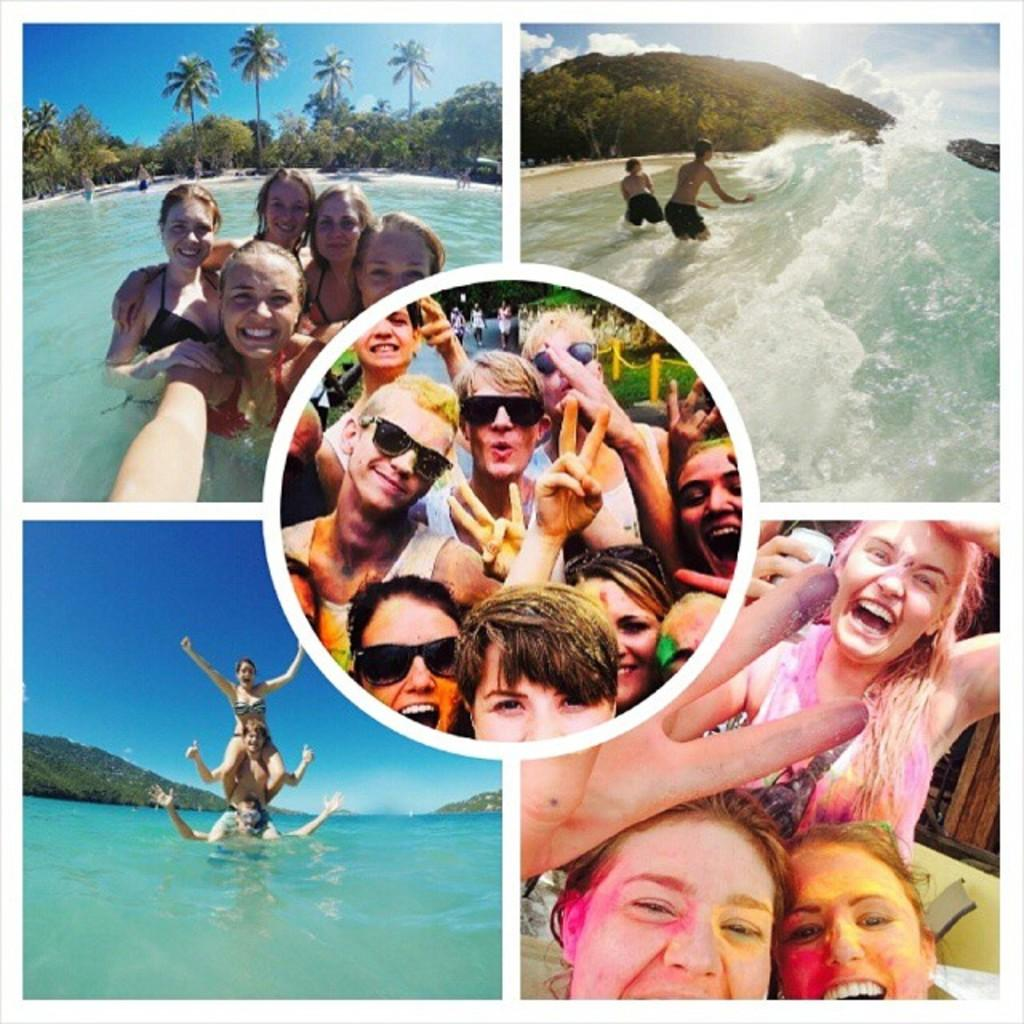How many pictures are present in the image? There are five different pictures in the image. What do two of the pictures have in common? Two of the pictures show only persons. In what context are the persons depicted in the remaining three pictures? Three of the pictures show persons in the water. What page of the book does the tin cover in the image? There is no book or tin present in the image. 